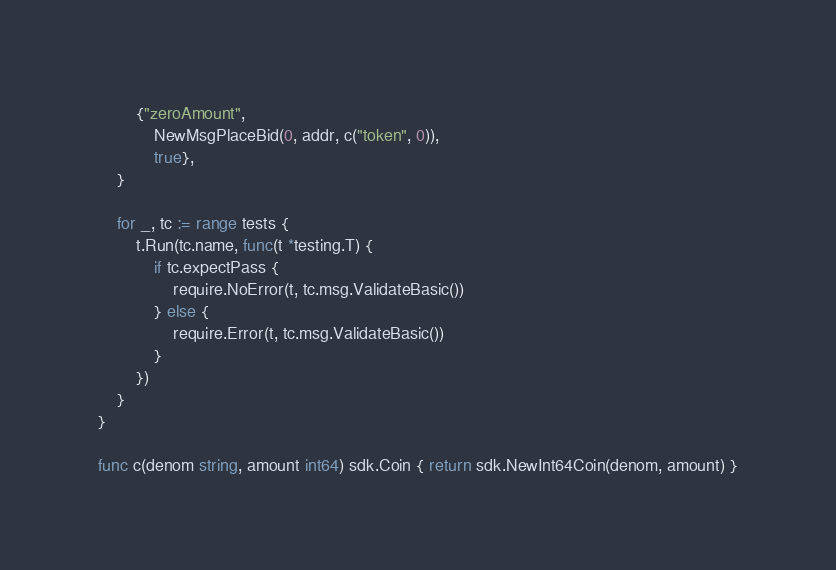Convert code to text. <code><loc_0><loc_0><loc_500><loc_500><_Go_>		{"zeroAmount",
			NewMsgPlaceBid(0, addr, c("token", 0)),
			true},
	}

	for _, tc := range tests {
		t.Run(tc.name, func(t *testing.T) {
			if tc.expectPass {
				require.NoError(t, tc.msg.ValidateBasic())
			} else {
				require.Error(t, tc.msg.ValidateBasic())
			}
		})
	}
}

func c(denom string, amount int64) sdk.Coin { return sdk.NewInt64Coin(denom, amount) }
</code> 